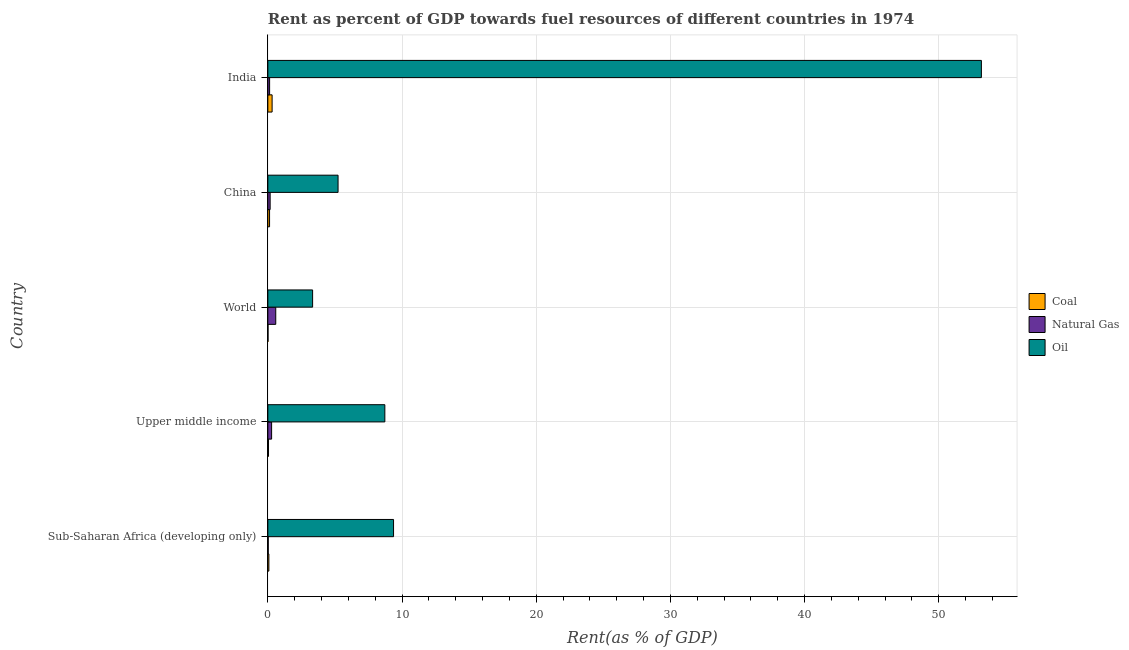How many groups of bars are there?
Make the answer very short. 5. How many bars are there on the 3rd tick from the top?
Make the answer very short. 3. How many bars are there on the 1st tick from the bottom?
Provide a succinct answer. 3. In how many cases, is the number of bars for a given country not equal to the number of legend labels?
Your response must be concise. 0. What is the rent towards natural gas in World?
Your answer should be compact. 0.59. Across all countries, what is the maximum rent towards oil?
Ensure brevity in your answer.  53.18. Across all countries, what is the minimum rent towards oil?
Your answer should be compact. 3.34. In which country was the rent towards oil maximum?
Provide a short and direct response. India. What is the total rent towards oil in the graph?
Your answer should be very brief. 79.84. What is the difference between the rent towards natural gas in India and that in Sub-Saharan Africa (developing only)?
Offer a terse response. 0.1. What is the difference between the rent towards natural gas in World and the rent towards coal in Upper middle income?
Keep it short and to the point. 0.54. What is the average rent towards natural gas per country?
Ensure brevity in your answer.  0.24. What is the difference between the rent towards natural gas and rent towards oil in World?
Give a very brief answer. -2.75. In how many countries, is the rent towards natural gas greater than 38 %?
Provide a succinct answer. 0. What is the ratio of the rent towards coal in China to that in Upper middle income?
Your answer should be very brief. 2.6. Is the difference between the rent towards oil in China and India greater than the difference between the rent towards natural gas in China and India?
Offer a terse response. No. What is the difference between the highest and the second highest rent towards coal?
Your answer should be compact. 0.19. What is the difference between the highest and the lowest rent towards coal?
Offer a terse response. 0.31. In how many countries, is the rent towards oil greater than the average rent towards oil taken over all countries?
Offer a terse response. 1. What does the 2nd bar from the top in India represents?
Offer a terse response. Natural Gas. What does the 2nd bar from the bottom in China represents?
Your answer should be compact. Natural Gas. How many bars are there?
Your answer should be very brief. 15. Are all the bars in the graph horizontal?
Your response must be concise. Yes. What is the difference between two consecutive major ticks on the X-axis?
Your answer should be compact. 10. Are the values on the major ticks of X-axis written in scientific E-notation?
Make the answer very short. No. Does the graph contain any zero values?
Give a very brief answer. No. Where does the legend appear in the graph?
Your answer should be compact. Center right. What is the title of the graph?
Give a very brief answer. Rent as percent of GDP towards fuel resources of different countries in 1974. What is the label or title of the X-axis?
Provide a short and direct response. Rent(as % of GDP). What is the Rent(as % of GDP) of Coal in Sub-Saharan Africa (developing only)?
Your answer should be compact. 0.08. What is the Rent(as % of GDP) in Natural Gas in Sub-Saharan Africa (developing only)?
Provide a succinct answer. 0.03. What is the Rent(as % of GDP) in Oil in Sub-Saharan Africa (developing only)?
Offer a terse response. 9.37. What is the Rent(as % of GDP) in Coal in Upper middle income?
Keep it short and to the point. 0.05. What is the Rent(as % of GDP) of Natural Gas in Upper middle income?
Keep it short and to the point. 0.28. What is the Rent(as % of GDP) of Oil in Upper middle income?
Your answer should be very brief. 8.72. What is the Rent(as % of GDP) in Coal in World?
Ensure brevity in your answer.  0.01. What is the Rent(as % of GDP) of Natural Gas in World?
Your answer should be compact. 0.59. What is the Rent(as % of GDP) in Oil in World?
Keep it short and to the point. 3.34. What is the Rent(as % of GDP) in Coal in China?
Ensure brevity in your answer.  0.13. What is the Rent(as % of GDP) of Natural Gas in China?
Your answer should be very brief. 0.17. What is the Rent(as % of GDP) in Oil in China?
Provide a short and direct response. 5.23. What is the Rent(as % of GDP) in Coal in India?
Provide a short and direct response. 0.32. What is the Rent(as % of GDP) in Natural Gas in India?
Your response must be concise. 0.13. What is the Rent(as % of GDP) of Oil in India?
Make the answer very short. 53.18. Across all countries, what is the maximum Rent(as % of GDP) in Coal?
Offer a very short reply. 0.32. Across all countries, what is the maximum Rent(as % of GDP) of Natural Gas?
Offer a terse response. 0.59. Across all countries, what is the maximum Rent(as % of GDP) of Oil?
Your answer should be very brief. 53.18. Across all countries, what is the minimum Rent(as % of GDP) of Coal?
Your answer should be very brief. 0.01. Across all countries, what is the minimum Rent(as % of GDP) in Natural Gas?
Keep it short and to the point. 0.03. Across all countries, what is the minimum Rent(as % of GDP) of Oil?
Provide a succinct answer. 3.34. What is the total Rent(as % of GDP) in Coal in the graph?
Ensure brevity in your answer.  0.58. What is the total Rent(as % of GDP) in Natural Gas in the graph?
Offer a terse response. 1.2. What is the total Rent(as % of GDP) of Oil in the graph?
Your answer should be compact. 79.84. What is the difference between the Rent(as % of GDP) in Coal in Sub-Saharan Africa (developing only) and that in Upper middle income?
Offer a very short reply. 0.03. What is the difference between the Rent(as % of GDP) in Natural Gas in Sub-Saharan Africa (developing only) and that in Upper middle income?
Give a very brief answer. -0.25. What is the difference between the Rent(as % of GDP) in Oil in Sub-Saharan Africa (developing only) and that in Upper middle income?
Provide a short and direct response. 0.65. What is the difference between the Rent(as % of GDP) in Coal in Sub-Saharan Africa (developing only) and that in World?
Your answer should be compact. 0.06. What is the difference between the Rent(as % of GDP) of Natural Gas in Sub-Saharan Africa (developing only) and that in World?
Provide a succinct answer. -0.56. What is the difference between the Rent(as % of GDP) of Oil in Sub-Saharan Africa (developing only) and that in World?
Make the answer very short. 6.03. What is the difference between the Rent(as % of GDP) in Coal in Sub-Saharan Africa (developing only) and that in China?
Provide a succinct answer. -0.05. What is the difference between the Rent(as % of GDP) in Natural Gas in Sub-Saharan Africa (developing only) and that in China?
Offer a very short reply. -0.14. What is the difference between the Rent(as % of GDP) in Oil in Sub-Saharan Africa (developing only) and that in China?
Offer a very short reply. 4.14. What is the difference between the Rent(as % of GDP) of Coal in Sub-Saharan Africa (developing only) and that in India?
Your answer should be compact. -0.24. What is the difference between the Rent(as % of GDP) of Natural Gas in Sub-Saharan Africa (developing only) and that in India?
Your answer should be compact. -0.1. What is the difference between the Rent(as % of GDP) of Oil in Sub-Saharan Africa (developing only) and that in India?
Make the answer very short. -43.81. What is the difference between the Rent(as % of GDP) in Coal in Upper middle income and that in World?
Make the answer very short. 0.04. What is the difference between the Rent(as % of GDP) in Natural Gas in Upper middle income and that in World?
Ensure brevity in your answer.  -0.31. What is the difference between the Rent(as % of GDP) of Oil in Upper middle income and that in World?
Keep it short and to the point. 5.38. What is the difference between the Rent(as % of GDP) in Coal in Upper middle income and that in China?
Ensure brevity in your answer.  -0.08. What is the difference between the Rent(as % of GDP) of Natural Gas in Upper middle income and that in China?
Offer a terse response. 0.11. What is the difference between the Rent(as % of GDP) in Oil in Upper middle income and that in China?
Keep it short and to the point. 3.49. What is the difference between the Rent(as % of GDP) in Coal in Upper middle income and that in India?
Ensure brevity in your answer.  -0.27. What is the difference between the Rent(as % of GDP) of Natural Gas in Upper middle income and that in India?
Your answer should be compact. 0.15. What is the difference between the Rent(as % of GDP) of Oil in Upper middle income and that in India?
Make the answer very short. -44.46. What is the difference between the Rent(as % of GDP) in Coal in World and that in China?
Provide a short and direct response. -0.12. What is the difference between the Rent(as % of GDP) in Natural Gas in World and that in China?
Your answer should be compact. 0.42. What is the difference between the Rent(as % of GDP) of Oil in World and that in China?
Provide a succinct answer. -1.9. What is the difference between the Rent(as % of GDP) in Coal in World and that in India?
Offer a very short reply. -0.31. What is the difference between the Rent(as % of GDP) in Natural Gas in World and that in India?
Your answer should be very brief. 0.46. What is the difference between the Rent(as % of GDP) in Oil in World and that in India?
Offer a very short reply. -49.85. What is the difference between the Rent(as % of GDP) of Coal in China and that in India?
Provide a short and direct response. -0.19. What is the difference between the Rent(as % of GDP) in Natural Gas in China and that in India?
Your answer should be very brief. 0.04. What is the difference between the Rent(as % of GDP) in Oil in China and that in India?
Your answer should be very brief. -47.95. What is the difference between the Rent(as % of GDP) of Coal in Sub-Saharan Africa (developing only) and the Rent(as % of GDP) of Natural Gas in Upper middle income?
Ensure brevity in your answer.  -0.2. What is the difference between the Rent(as % of GDP) in Coal in Sub-Saharan Africa (developing only) and the Rent(as % of GDP) in Oil in Upper middle income?
Give a very brief answer. -8.64. What is the difference between the Rent(as % of GDP) of Natural Gas in Sub-Saharan Africa (developing only) and the Rent(as % of GDP) of Oil in Upper middle income?
Make the answer very short. -8.69. What is the difference between the Rent(as % of GDP) of Coal in Sub-Saharan Africa (developing only) and the Rent(as % of GDP) of Natural Gas in World?
Your answer should be very brief. -0.51. What is the difference between the Rent(as % of GDP) of Coal in Sub-Saharan Africa (developing only) and the Rent(as % of GDP) of Oil in World?
Offer a very short reply. -3.26. What is the difference between the Rent(as % of GDP) of Natural Gas in Sub-Saharan Africa (developing only) and the Rent(as % of GDP) of Oil in World?
Make the answer very short. -3.31. What is the difference between the Rent(as % of GDP) in Coal in Sub-Saharan Africa (developing only) and the Rent(as % of GDP) in Natural Gas in China?
Your answer should be very brief. -0.09. What is the difference between the Rent(as % of GDP) in Coal in Sub-Saharan Africa (developing only) and the Rent(as % of GDP) in Oil in China?
Give a very brief answer. -5.16. What is the difference between the Rent(as % of GDP) of Natural Gas in Sub-Saharan Africa (developing only) and the Rent(as % of GDP) of Oil in China?
Your answer should be very brief. -5.2. What is the difference between the Rent(as % of GDP) in Coal in Sub-Saharan Africa (developing only) and the Rent(as % of GDP) in Natural Gas in India?
Make the answer very short. -0.06. What is the difference between the Rent(as % of GDP) in Coal in Sub-Saharan Africa (developing only) and the Rent(as % of GDP) in Oil in India?
Your answer should be very brief. -53.11. What is the difference between the Rent(as % of GDP) in Natural Gas in Sub-Saharan Africa (developing only) and the Rent(as % of GDP) in Oil in India?
Offer a very short reply. -53.15. What is the difference between the Rent(as % of GDP) of Coal in Upper middle income and the Rent(as % of GDP) of Natural Gas in World?
Provide a succinct answer. -0.54. What is the difference between the Rent(as % of GDP) in Coal in Upper middle income and the Rent(as % of GDP) in Oil in World?
Make the answer very short. -3.29. What is the difference between the Rent(as % of GDP) of Natural Gas in Upper middle income and the Rent(as % of GDP) of Oil in World?
Offer a terse response. -3.06. What is the difference between the Rent(as % of GDP) in Coal in Upper middle income and the Rent(as % of GDP) in Natural Gas in China?
Give a very brief answer. -0.12. What is the difference between the Rent(as % of GDP) of Coal in Upper middle income and the Rent(as % of GDP) of Oil in China?
Provide a short and direct response. -5.18. What is the difference between the Rent(as % of GDP) of Natural Gas in Upper middle income and the Rent(as % of GDP) of Oil in China?
Give a very brief answer. -4.95. What is the difference between the Rent(as % of GDP) in Coal in Upper middle income and the Rent(as % of GDP) in Natural Gas in India?
Offer a terse response. -0.08. What is the difference between the Rent(as % of GDP) of Coal in Upper middle income and the Rent(as % of GDP) of Oil in India?
Keep it short and to the point. -53.13. What is the difference between the Rent(as % of GDP) in Natural Gas in Upper middle income and the Rent(as % of GDP) in Oil in India?
Offer a very short reply. -52.9. What is the difference between the Rent(as % of GDP) in Coal in World and the Rent(as % of GDP) in Natural Gas in China?
Provide a short and direct response. -0.16. What is the difference between the Rent(as % of GDP) in Coal in World and the Rent(as % of GDP) in Oil in China?
Ensure brevity in your answer.  -5.22. What is the difference between the Rent(as % of GDP) of Natural Gas in World and the Rent(as % of GDP) of Oil in China?
Your response must be concise. -4.64. What is the difference between the Rent(as % of GDP) in Coal in World and the Rent(as % of GDP) in Natural Gas in India?
Offer a very short reply. -0.12. What is the difference between the Rent(as % of GDP) of Coal in World and the Rent(as % of GDP) of Oil in India?
Your answer should be compact. -53.17. What is the difference between the Rent(as % of GDP) in Natural Gas in World and the Rent(as % of GDP) in Oil in India?
Ensure brevity in your answer.  -52.59. What is the difference between the Rent(as % of GDP) of Coal in China and the Rent(as % of GDP) of Natural Gas in India?
Your response must be concise. -0. What is the difference between the Rent(as % of GDP) in Coal in China and the Rent(as % of GDP) in Oil in India?
Your answer should be very brief. -53.06. What is the difference between the Rent(as % of GDP) in Natural Gas in China and the Rent(as % of GDP) in Oil in India?
Ensure brevity in your answer.  -53.01. What is the average Rent(as % of GDP) of Coal per country?
Ensure brevity in your answer.  0.12. What is the average Rent(as % of GDP) of Natural Gas per country?
Your answer should be compact. 0.24. What is the average Rent(as % of GDP) in Oil per country?
Ensure brevity in your answer.  15.97. What is the difference between the Rent(as % of GDP) in Coal and Rent(as % of GDP) in Natural Gas in Sub-Saharan Africa (developing only)?
Offer a terse response. 0.05. What is the difference between the Rent(as % of GDP) in Coal and Rent(as % of GDP) in Oil in Sub-Saharan Africa (developing only)?
Your answer should be compact. -9.29. What is the difference between the Rent(as % of GDP) of Natural Gas and Rent(as % of GDP) of Oil in Sub-Saharan Africa (developing only)?
Make the answer very short. -9.34. What is the difference between the Rent(as % of GDP) of Coal and Rent(as % of GDP) of Natural Gas in Upper middle income?
Provide a short and direct response. -0.23. What is the difference between the Rent(as % of GDP) of Coal and Rent(as % of GDP) of Oil in Upper middle income?
Offer a very short reply. -8.67. What is the difference between the Rent(as % of GDP) of Natural Gas and Rent(as % of GDP) of Oil in Upper middle income?
Offer a terse response. -8.44. What is the difference between the Rent(as % of GDP) of Coal and Rent(as % of GDP) of Natural Gas in World?
Keep it short and to the point. -0.58. What is the difference between the Rent(as % of GDP) of Coal and Rent(as % of GDP) of Oil in World?
Your answer should be very brief. -3.32. What is the difference between the Rent(as % of GDP) of Natural Gas and Rent(as % of GDP) of Oil in World?
Offer a very short reply. -2.75. What is the difference between the Rent(as % of GDP) of Coal and Rent(as % of GDP) of Natural Gas in China?
Provide a succinct answer. -0.04. What is the difference between the Rent(as % of GDP) of Coal and Rent(as % of GDP) of Oil in China?
Offer a very short reply. -5.11. What is the difference between the Rent(as % of GDP) of Natural Gas and Rent(as % of GDP) of Oil in China?
Offer a terse response. -5.06. What is the difference between the Rent(as % of GDP) of Coal and Rent(as % of GDP) of Natural Gas in India?
Your answer should be compact. 0.19. What is the difference between the Rent(as % of GDP) in Coal and Rent(as % of GDP) in Oil in India?
Offer a terse response. -52.87. What is the difference between the Rent(as % of GDP) in Natural Gas and Rent(as % of GDP) in Oil in India?
Your response must be concise. -53.05. What is the ratio of the Rent(as % of GDP) of Coal in Sub-Saharan Africa (developing only) to that in Upper middle income?
Your response must be concise. 1.55. What is the ratio of the Rent(as % of GDP) of Natural Gas in Sub-Saharan Africa (developing only) to that in Upper middle income?
Your response must be concise. 0.11. What is the ratio of the Rent(as % of GDP) in Oil in Sub-Saharan Africa (developing only) to that in Upper middle income?
Offer a terse response. 1.07. What is the ratio of the Rent(as % of GDP) of Coal in Sub-Saharan Africa (developing only) to that in World?
Offer a terse response. 6.25. What is the ratio of the Rent(as % of GDP) of Natural Gas in Sub-Saharan Africa (developing only) to that in World?
Your response must be concise. 0.05. What is the ratio of the Rent(as % of GDP) in Oil in Sub-Saharan Africa (developing only) to that in World?
Provide a succinct answer. 2.81. What is the ratio of the Rent(as % of GDP) in Coal in Sub-Saharan Africa (developing only) to that in China?
Your answer should be compact. 0.6. What is the ratio of the Rent(as % of GDP) of Natural Gas in Sub-Saharan Africa (developing only) to that in China?
Provide a short and direct response. 0.18. What is the ratio of the Rent(as % of GDP) of Oil in Sub-Saharan Africa (developing only) to that in China?
Ensure brevity in your answer.  1.79. What is the ratio of the Rent(as % of GDP) of Coal in Sub-Saharan Africa (developing only) to that in India?
Provide a short and direct response. 0.24. What is the ratio of the Rent(as % of GDP) in Natural Gas in Sub-Saharan Africa (developing only) to that in India?
Give a very brief answer. 0.23. What is the ratio of the Rent(as % of GDP) of Oil in Sub-Saharan Africa (developing only) to that in India?
Keep it short and to the point. 0.18. What is the ratio of the Rent(as % of GDP) of Coal in Upper middle income to that in World?
Give a very brief answer. 4.04. What is the ratio of the Rent(as % of GDP) in Natural Gas in Upper middle income to that in World?
Offer a terse response. 0.48. What is the ratio of the Rent(as % of GDP) of Oil in Upper middle income to that in World?
Provide a short and direct response. 2.61. What is the ratio of the Rent(as % of GDP) of Coal in Upper middle income to that in China?
Provide a succinct answer. 0.38. What is the ratio of the Rent(as % of GDP) of Natural Gas in Upper middle income to that in China?
Your answer should be compact. 1.64. What is the ratio of the Rent(as % of GDP) of Oil in Upper middle income to that in China?
Keep it short and to the point. 1.67. What is the ratio of the Rent(as % of GDP) in Coal in Upper middle income to that in India?
Provide a short and direct response. 0.16. What is the ratio of the Rent(as % of GDP) of Natural Gas in Upper middle income to that in India?
Offer a very short reply. 2.13. What is the ratio of the Rent(as % of GDP) in Oil in Upper middle income to that in India?
Make the answer very short. 0.16. What is the ratio of the Rent(as % of GDP) in Coal in World to that in China?
Keep it short and to the point. 0.1. What is the ratio of the Rent(as % of GDP) in Natural Gas in World to that in China?
Offer a very short reply. 3.44. What is the ratio of the Rent(as % of GDP) of Oil in World to that in China?
Keep it short and to the point. 0.64. What is the ratio of the Rent(as % of GDP) in Coal in World to that in India?
Your response must be concise. 0.04. What is the ratio of the Rent(as % of GDP) in Natural Gas in World to that in India?
Your response must be concise. 4.46. What is the ratio of the Rent(as % of GDP) of Oil in World to that in India?
Provide a succinct answer. 0.06. What is the ratio of the Rent(as % of GDP) in Coal in China to that in India?
Provide a succinct answer. 0.4. What is the ratio of the Rent(as % of GDP) of Natural Gas in China to that in India?
Provide a succinct answer. 1.3. What is the ratio of the Rent(as % of GDP) of Oil in China to that in India?
Your response must be concise. 0.1. What is the difference between the highest and the second highest Rent(as % of GDP) in Coal?
Your answer should be very brief. 0.19. What is the difference between the highest and the second highest Rent(as % of GDP) of Natural Gas?
Offer a terse response. 0.31. What is the difference between the highest and the second highest Rent(as % of GDP) in Oil?
Your answer should be very brief. 43.81. What is the difference between the highest and the lowest Rent(as % of GDP) in Coal?
Keep it short and to the point. 0.31. What is the difference between the highest and the lowest Rent(as % of GDP) in Natural Gas?
Provide a succinct answer. 0.56. What is the difference between the highest and the lowest Rent(as % of GDP) of Oil?
Your answer should be compact. 49.85. 